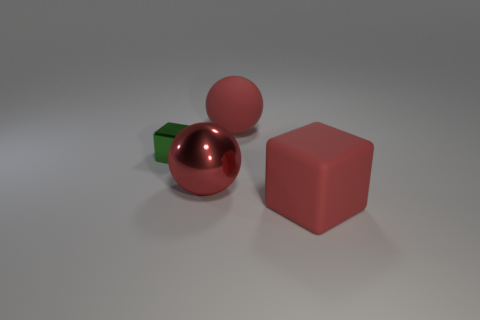There is a matte object that is behind the big rubber cube; is its color the same as the metallic sphere?
Offer a very short reply. Yes. What is the shape of the big metallic thing that is the same color as the matte ball?
Offer a very short reply. Sphere. There is a block that is behind the big matte object in front of the metal thing behind the big red metal object; what is its material?
Keep it short and to the point. Metal. What color is the rubber thing behind the block that is right of the metallic ball?
Give a very brief answer. Red. There is a shiny sphere that is the same size as the matte block; what is its color?
Your response must be concise. Red. What number of tiny objects are either green cylinders or cubes?
Make the answer very short. 1. Are there more large balls that are right of the tiny green metal thing than green objects that are behind the large red rubber sphere?
Ensure brevity in your answer.  Yes. What number of other objects are there of the same size as the red block?
Your answer should be very brief. 2. Is the material of the big red ball that is behind the metallic cube the same as the red cube?
Provide a short and direct response. Yes. What number of other objects are the same color as the tiny metallic object?
Offer a very short reply. 0. 